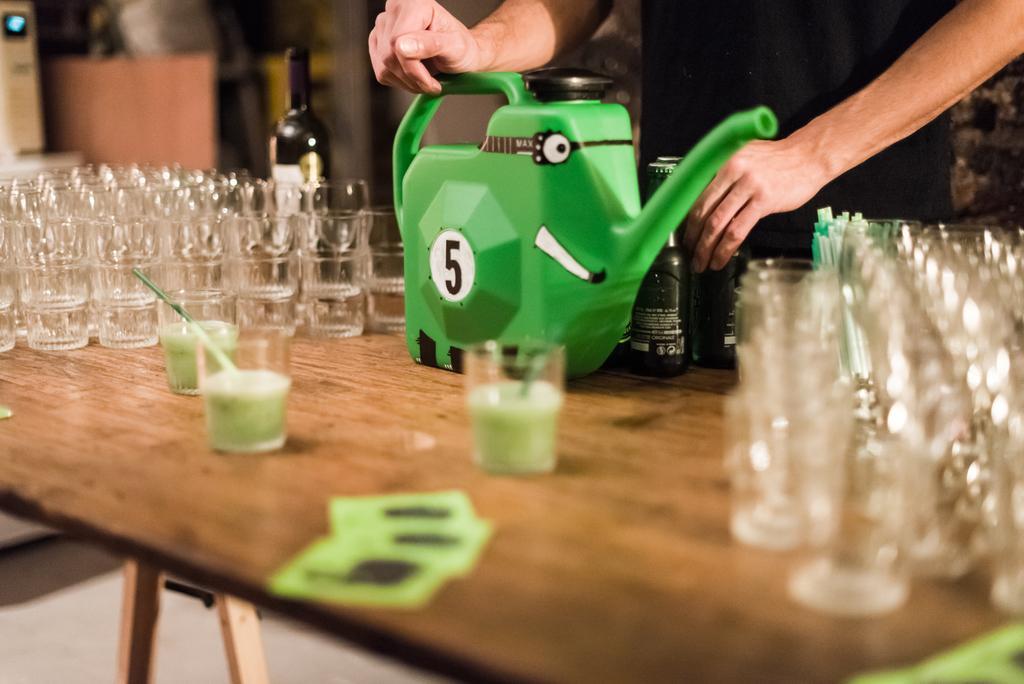How would you summarize this image in a sentence or two? In this image i can see few glass, a straw,a cane,two bottles on a table,at the back ground i can see a person standing. 